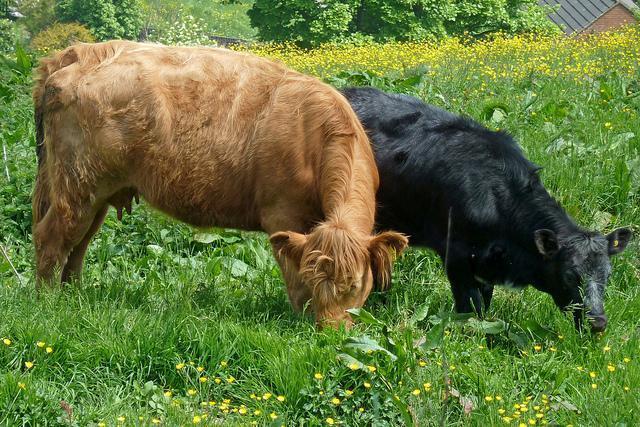How many animals are eating?
Give a very brief answer. 2. How many cows are in the picture?
Give a very brief answer. 2. How many giraffes are there?
Give a very brief answer. 0. 